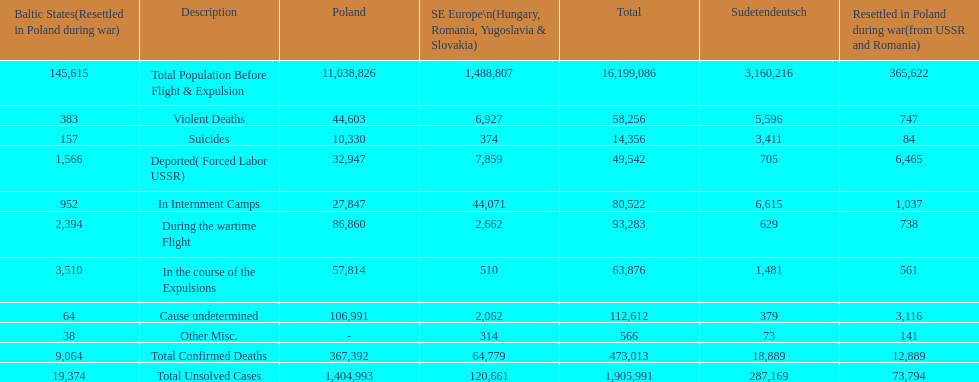Can you give me this table as a dict? {'header': ['Baltic States(Resettled in Poland during war)', 'Description', 'Poland', 'SE Europe\\n(Hungary, Romania, Yugoslavia & Slovakia)', 'Total', 'Sudetendeutsch', 'Resettled in Poland during war(from USSR and Romania)'], 'rows': [['145,615', 'Total Population Before Flight & Expulsion', '11,038,826', '1,488,807', '16,199,086', '3,160,216', '365,622'], ['383', 'Violent Deaths', '44,603', '6,927', '58,256', '5,596', '747'], ['157', 'Suicides', '10,330', '374', '14,356', '3,411', '84'], ['1,566', 'Deported( Forced Labor USSR)', '32,947', '7,859', '49,542', '705', '6,465'], ['952', 'In Internment Camps', '27,847', '44,071', '80,522', '6,615', '1,037'], ['2,394', 'During the wartime Flight', '86,860', '2,662', '93,283', '629', '738'], ['3,510', 'In the course of the Expulsions', '57,814', '510', '63,876', '1,481', '561'], ['64', 'Cause undetermined', '106,991', '2,062', '112,612', '379', '3,116'], ['38', 'Other Misc.', '-', '314', '566', '73', '141'], ['9,064', 'Total Confirmed Deaths', '367,392', '64,779', '473,013', '18,889', '12,889'], ['19,374', 'Total Unsolved Cases', '1,404,993', '120,661', '1,905,991', '287,169', '73,794']]} What was the cause of the most deaths? Cause undetermined. 